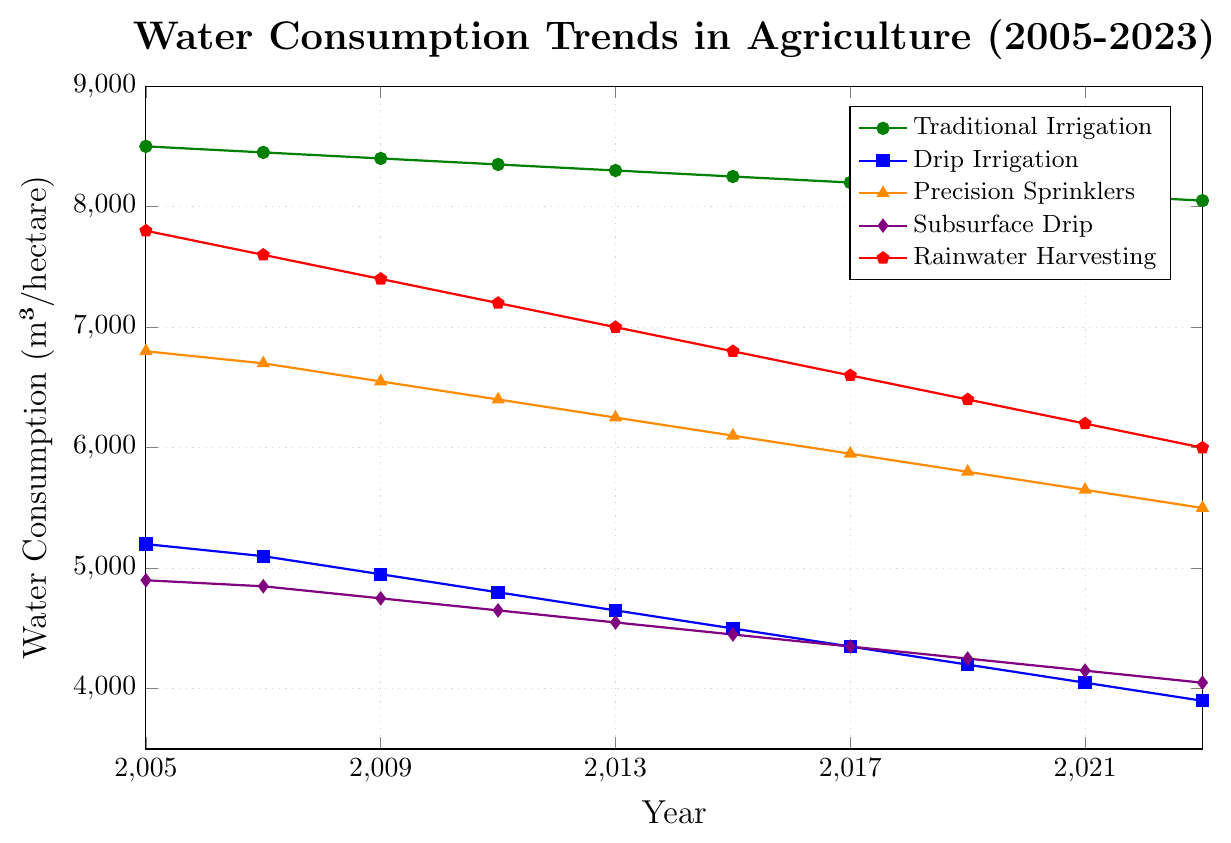Which irrigation method used the least water in 2023? According to the plot, the method with the lowest water consumption in 2023 is the one with the lowest point on the y-axis for that year, which is Drip Irrigation.
Answer: Drip Irrigation By how much did traditional irrigation water usage decrease from 2005 to 2023? Subtract the water consumption value for traditional irrigation in 2023 from the value in 2005: 8500 (2005) - 8050 (2023).
Answer: 450 Which irrigation method shows the steepest decrease in water consumption from 2005 to 2023? The steepest decrease corresponds to the line with the greatest negative slope from 2005 to 2023. Drip Irrigation decreases from 5200 to 3900, a difference of 1300, which appears to be the steepest.
Answer: Drip Irrigation What is the average water consumption of rainwater harvesting from 2005 to 2023? Sum the water consumption values for each year and divide by the number of years: (7800 + 7600 + 7400 + 7200 + 7000 + 6800 + 6600 + 6400 + 6200 + 6000) / 10.
Answer: 6900 In which year did subsurface drip irrigation reach below 4500 m³/hectare for the first time? Identify the year in the plot where the subsurface drip line first drops below the 4500 mark, which is around 2015.
Answer: 2015 Compare the water consumption of traditional irrigation and rainwater harvesting in 2011. Check the y-values for both traditional irrigation and rainwater harvesting in the year 2011. Traditional irrigation is at 8350 m³/hectare, and rainwater harvesting is at 7200 m³/hectare.
Answer: Traditional irrigation uses more water What is the total reduction in water consumption for subsurface drip irrigation from 2005 to 2023? Subtract the subsurface drip consumption in 2023 from the value in 2005: 4900 (2005) - 4050 (2023).
Answer: 850 Which irrigation method consistently decreased its water usage every observed year? Look for the lines that show a consistent downward trend without any increases from one year to the next. Both Drip Irrigation and Subsurface Drip show consistent decreases.
Answer: Drip Irrigation and Subsurface Drip 